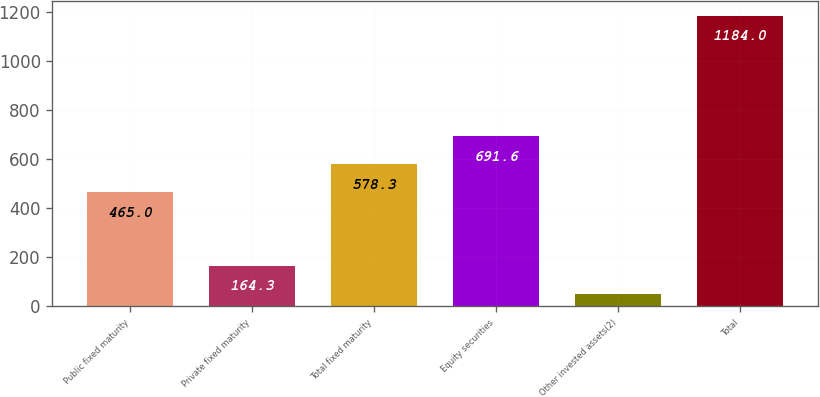Convert chart. <chart><loc_0><loc_0><loc_500><loc_500><bar_chart><fcel>Public fixed maturity<fcel>Private fixed maturity<fcel>Total fixed maturity<fcel>Equity securities<fcel>Other invested assets(2)<fcel>Total<nl><fcel>465<fcel>164.3<fcel>578.3<fcel>691.6<fcel>51<fcel>1184<nl></chart> 